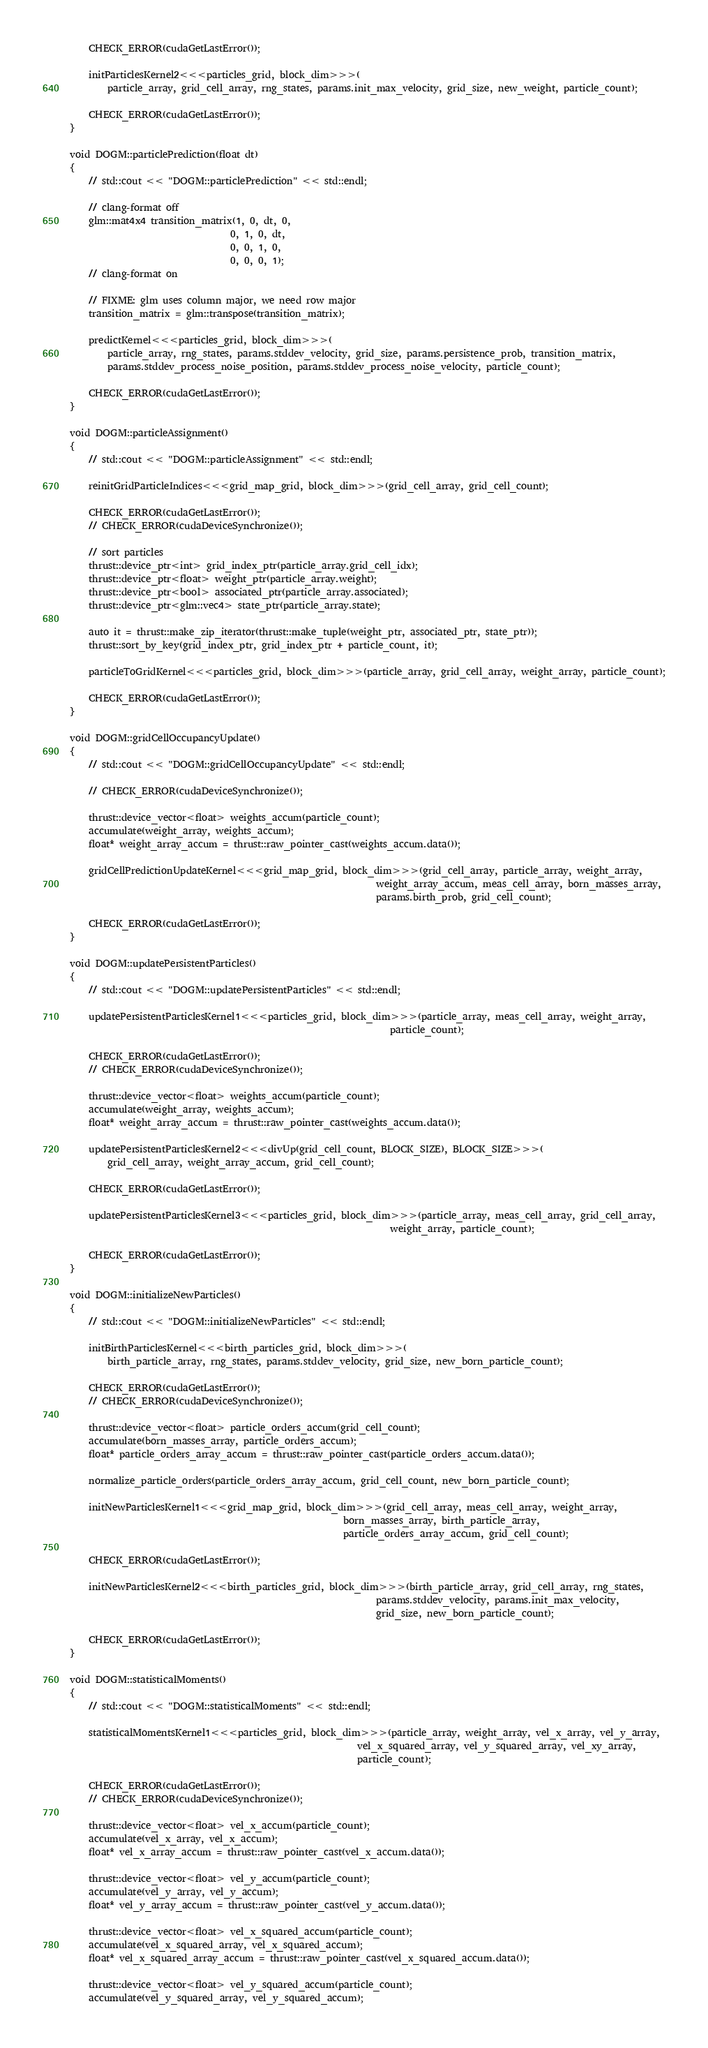<code> <loc_0><loc_0><loc_500><loc_500><_Cuda_>
    CHECK_ERROR(cudaGetLastError());

    initParticlesKernel2<<<particles_grid, block_dim>>>(
        particle_array, grid_cell_array, rng_states, params.init_max_velocity, grid_size, new_weight, particle_count);

    CHECK_ERROR(cudaGetLastError());
}

void DOGM::particlePrediction(float dt)
{
    // std::cout << "DOGM::particlePrediction" << std::endl;

    // clang-format off
    glm::mat4x4 transition_matrix(1, 0, dt, 0,
                                  0, 1, 0, dt,
                                  0, 0, 1, 0,
                                  0, 0, 0, 1);
    // clang-format on

    // FIXME: glm uses column major, we need row major
    transition_matrix = glm::transpose(transition_matrix);

    predictKernel<<<particles_grid, block_dim>>>(
        particle_array, rng_states, params.stddev_velocity, grid_size, params.persistence_prob, transition_matrix,
        params.stddev_process_noise_position, params.stddev_process_noise_velocity, particle_count);

    CHECK_ERROR(cudaGetLastError());
}

void DOGM::particleAssignment()
{
    // std::cout << "DOGM::particleAssignment" << std::endl;

    reinitGridParticleIndices<<<grid_map_grid, block_dim>>>(grid_cell_array, grid_cell_count);

    CHECK_ERROR(cudaGetLastError());
    // CHECK_ERROR(cudaDeviceSynchronize());

    // sort particles
    thrust::device_ptr<int> grid_index_ptr(particle_array.grid_cell_idx);
    thrust::device_ptr<float> weight_ptr(particle_array.weight);
    thrust::device_ptr<bool> associated_ptr(particle_array.associated);
    thrust::device_ptr<glm::vec4> state_ptr(particle_array.state);

    auto it = thrust::make_zip_iterator(thrust::make_tuple(weight_ptr, associated_ptr, state_ptr));
    thrust::sort_by_key(grid_index_ptr, grid_index_ptr + particle_count, it);

    particleToGridKernel<<<particles_grid, block_dim>>>(particle_array, grid_cell_array, weight_array, particle_count);

    CHECK_ERROR(cudaGetLastError());
}

void DOGM::gridCellOccupancyUpdate()
{
    // std::cout << "DOGM::gridCellOccupancyUpdate" << std::endl;

    // CHECK_ERROR(cudaDeviceSynchronize());

    thrust::device_vector<float> weights_accum(particle_count);
    accumulate(weight_array, weights_accum);
    float* weight_array_accum = thrust::raw_pointer_cast(weights_accum.data());

    gridCellPredictionUpdateKernel<<<grid_map_grid, block_dim>>>(grid_cell_array, particle_array, weight_array,
                                                                 weight_array_accum, meas_cell_array, born_masses_array,
                                                                 params.birth_prob, grid_cell_count);

    CHECK_ERROR(cudaGetLastError());
}

void DOGM::updatePersistentParticles()
{
    // std::cout << "DOGM::updatePersistentParticles" << std::endl;

    updatePersistentParticlesKernel1<<<particles_grid, block_dim>>>(particle_array, meas_cell_array, weight_array,
                                                                    particle_count);

    CHECK_ERROR(cudaGetLastError());
    // CHECK_ERROR(cudaDeviceSynchronize());

    thrust::device_vector<float> weights_accum(particle_count);
    accumulate(weight_array, weights_accum);
    float* weight_array_accum = thrust::raw_pointer_cast(weights_accum.data());

    updatePersistentParticlesKernel2<<<divUp(grid_cell_count, BLOCK_SIZE), BLOCK_SIZE>>>(
        grid_cell_array, weight_array_accum, grid_cell_count);

    CHECK_ERROR(cudaGetLastError());

    updatePersistentParticlesKernel3<<<particles_grid, block_dim>>>(particle_array, meas_cell_array, grid_cell_array,
                                                                    weight_array, particle_count);

    CHECK_ERROR(cudaGetLastError());
}

void DOGM::initializeNewParticles()
{
    // std::cout << "DOGM::initializeNewParticles" << std::endl;

    initBirthParticlesKernel<<<birth_particles_grid, block_dim>>>(
        birth_particle_array, rng_states, params.stddev_velocity, grid_size, new_born_particle_count);

    CHECK_ERROR(cudaGetLastError());
    // CHECK_ERROR(cudaDeviceSynchronize());

    thrust::device_vector<float> particle_orders_accum(grid_cell_count);
    accumulate(born_masses_array, particle_orders_accum);
    float* particle_orders_array_accum = thrust::raw_pointer_cast(particle_orders_accum.data());

    normalize_particle_orders(particle_orders_array_accum, grid_cell_count, new_born_particle_count);

    initNewParticlesKernel1<<<grid_map_grid, block_dim>>>(grid_cell_array, meas_cell_array, weight_array,
                                                          born_masses_array, birth_particle_array,
                                                          particle_orders_array_accum, grid_cell_count);

    CHECK_ERROR(cudaGetLastError());

    initNewParticlesKernel2<<<birth_particles_grid, block_dim>>>(birth_particle_array, grid_cell_array, rng_states,
                                                                 params.stddev_velocity, params.init_max_velocity,
                                                                 grid_size, new_born_particle_count);

    CHECK_ERROR(cudaGetLastError());
}

void DOGM::statisticalMoments()
{
    // std::cout << "DOGM::statisticalMoments" << std::endl;

    statisticalMomentsKernel1<<<particles_grid, block_dim>>>(particle_array, weight_array, vel_x_array, vel_y_array,
                                                             vel_x_squared_array, vel_y_squared_array, vel_xy_array,
                                                             particle_count);

    CHECK_ERROR(cudaGetLastError());
    // CHECK_ERROR(cudaDeviceSynchronize());

    thrust::device_vector<float> vel_x_accum(particle_count);
    accumulate(vel_x_array, vel_x_accum);
    float* vel_x_array_accum = thrust::raw_pointer_cast(vel_x_accum.data());

    thrust::device_vector<float> vel_y_accum(particle_count);
    accumulate(vel_y_array, vel_y_accum);
    float* vel_y_array_accum = thrust::raw_pointer_cast(vel_y_accum.data());

    thrust::device_vector<float> vel_x_squared_accum(particle_count);
    accumulate(vel_x_squared_array, vel_x_squared_accum);
    float* vel_x_squared_array_accum = thrust::raw_pointer_cast(vel_x_squared_accum.data());

    thrust::device_vector<float> vel_y_squared_accum(particle_count);
    accumulate(vel_y_squared_array, vel_y_squared_accum);</code> 